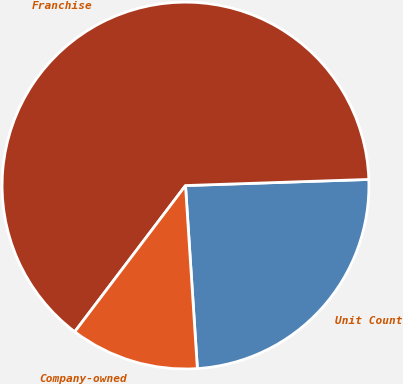Convert chart. <chart><loc_0><loc_0><loc_500><loc_500><pie_chart><fcel>Unit Count<fcel>Franchise<fcel>Company-owned<nl><fcel>24.5%<fcel>64.15%<fcel>11.35%<nl></chart> 